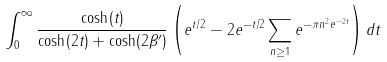Convert formula to latex. <formula><loc_0><loc_0><loc_500><loc_500>\int _ { 0 } ^ { \infty } \frac { \cosh ( t ) } { \cosh ( 2 t ) + \cosh ( 2 \beta ^ { \prime } ) } \left ( e ^ { t / 2 } - 2 e ^ { - t / 2 } \sum _ { n \geq 1 } e ^ { - \pi n ^ { 2 } e ^ { - 2 t } } \right ) d t</formula> 